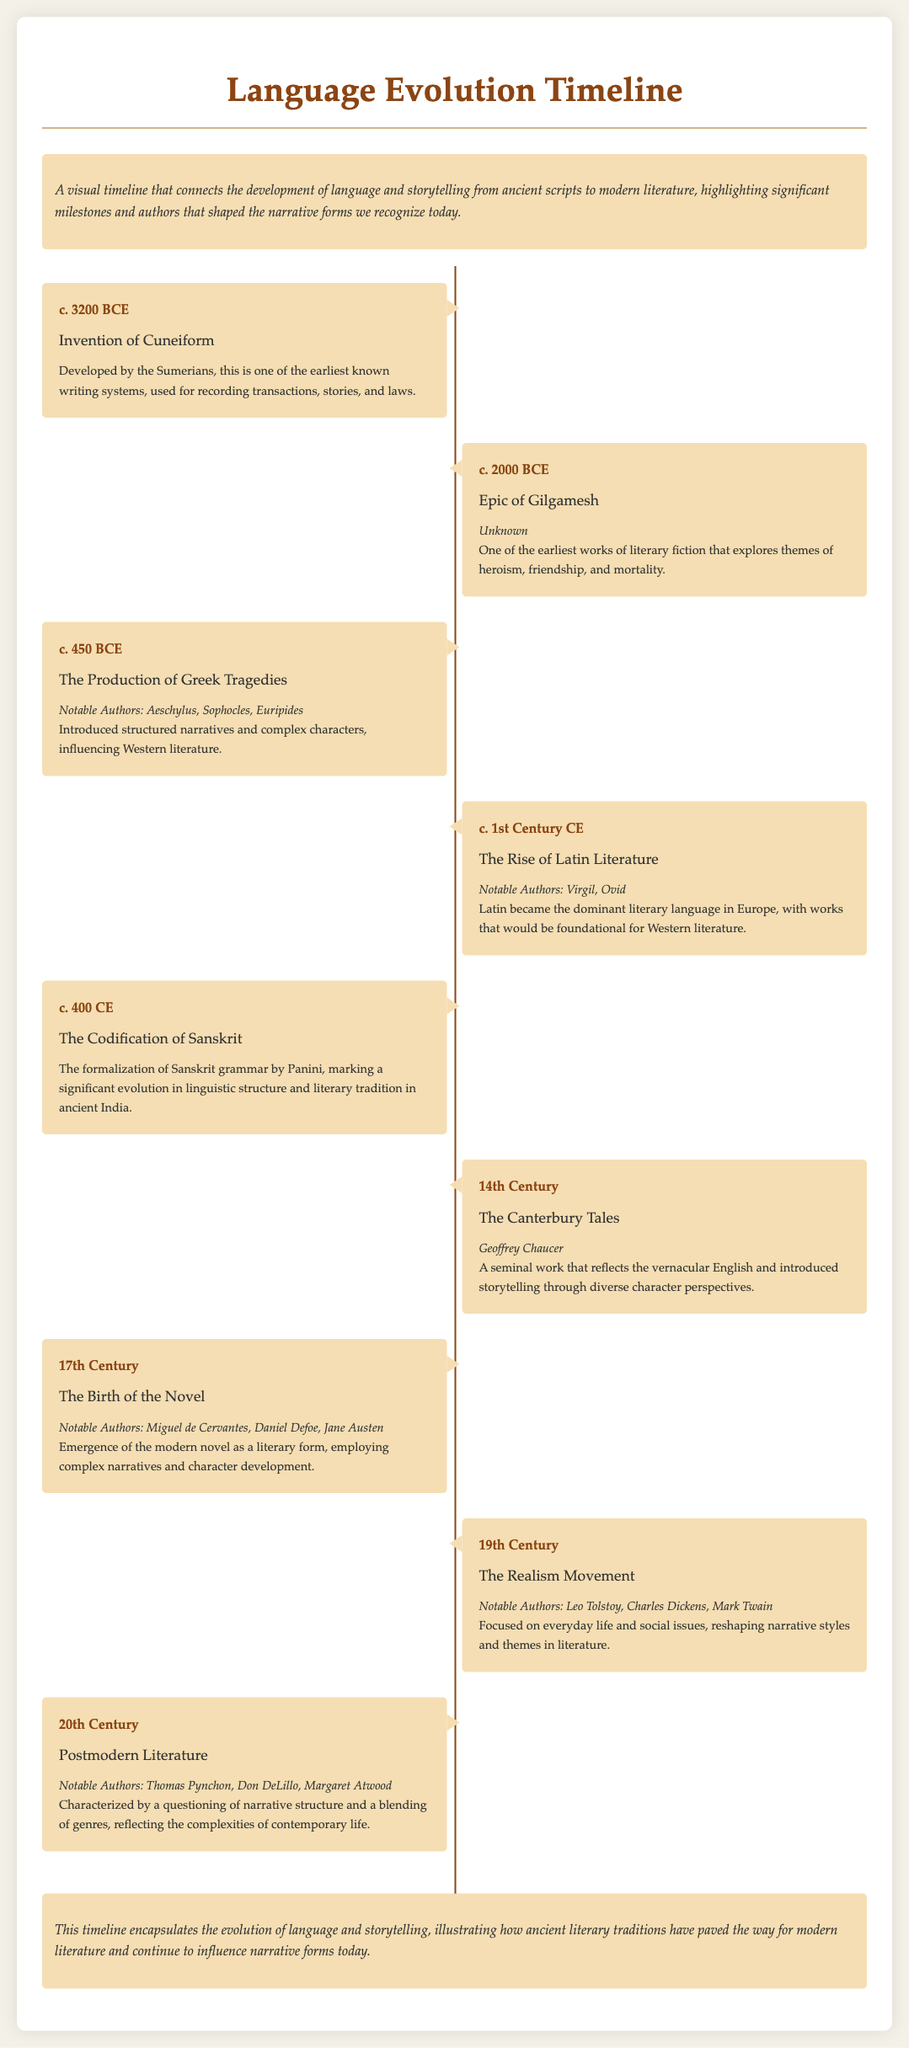What is the earliest date mentioned in the timeline? The timeline begins with the invention of Cuneiform around c. 3200 BCE as its earliest date.
Answer: c. 3200 BCE Who is the author of The Canterbury Tales? The milestone for The Canterbury Tales includes Geoffrey Chaucer as the author.
Answer: Geoffrey Chaucer What significant work was produced around c. 2000 BCE? The timeline highlights the Epic of Gilgamesh as a significant work produced around that time.
Answer: Epic of Gilgamesh Which authors are associated with the 17th Century milestone? The milestone mentions authors like Miguel de Cervantes and Jane Austen as notable contributors to the Birth of the Novel.
Answer: Miguel de Cervantes, Daniel Defoe, Jane Austen What key literary form emerged in the 17th Century? The timeline indicates the emergence of the modern novel as a key literary form in this period.
Answer: The modern novel According to the timeline, what literary tradition was formally codified around 400 CE? The codification of Sanskrit is mentioned in the timeline as a significant development in linguistic structure and literary tradition around that time.
Answer: Sanskrit Which century marks the beginning of the Realism Movement? The timeline specifies the 19th Century as the period when the Realism Movement began.
Answer: 19th Century What type of literature characterized the 20th Century? Postmodern literature is described as the prevailing type of literature during the 20th Century in the document.
Answer: Postmodern literature 